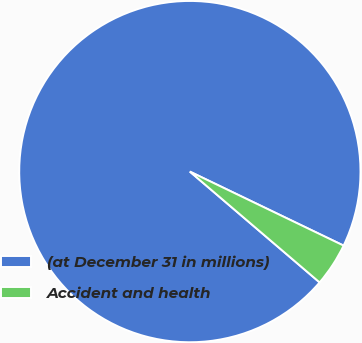Convert chart. <chart><loc_0><loc_0><loc_500><loc_500><pie_chart><fcel>(at December 31 in millions)<fcel>Accident and health<nl><fcel>95.89%<fcel>4.11%<nl></chart> 